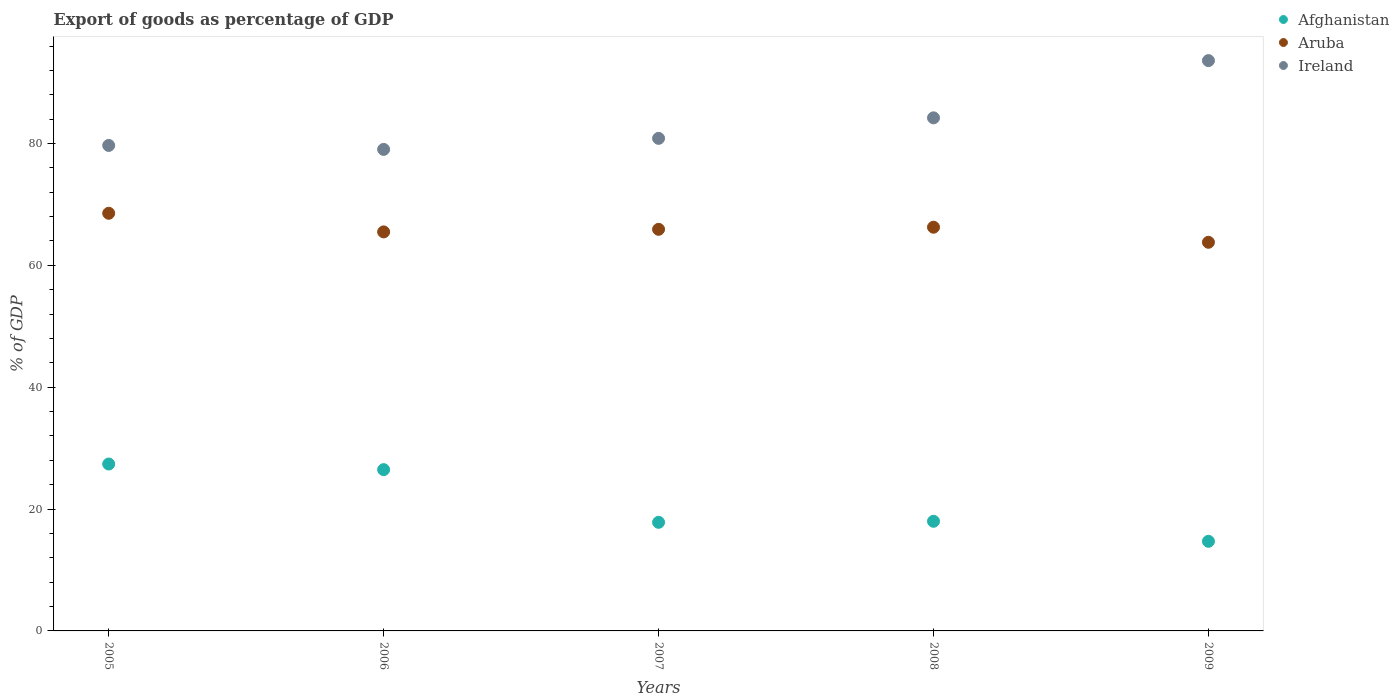What is the export of goods as percentage of GDP in Ireland in 2008?
Make the answer very short. 84.21. Across all years, what is the maximum export of goods as percentage of GDP in Ireland?
Your answer should be compact. 93.6. Across all years, what is the minimum export of goods as percentage of GDP in Ireland?
Provide a short and direct response. 79.03. In which year was the export of goods as percentage of GDP in Ireland maximum?
Offer a very short reply. 2009. What is the total export of goods as percentage of GDP in Afghanistan in the graph?
Your response must be concise. 104.39. What is the difference between the export of goods as percentage of GDP in Afghanistan in 2006 and that in 2007?
Offer a terse response. 8.65. What is the difference between the export of goods as percentage of GDP in Ireland in 2005 and the export of goods as percentage of GDP in Aruba in 2009?
Provide a succinct answer. 15.9. What is the average export of goods as percentage of GDP in Aruba per year?
Give a very brief answer. 66. In the year 2009, what is the difference between the export of goods as percentage of GDP in Afghanistan and export of goods as percentage of GDP in Aruba?
Your answer should be compact. -49.08. What is the ratio of the export of goods as percentage of GDP in Aruba in 2007 to that in 2008?
Provide a short and direct response. 0.99. What is the difference between the highest and the second highest export of goods as percentage of GDP in Afghanistan?
Give a very brief answer. 0.92. What is the difference between the highest and the lowest export of goods as percentage of GDP in Aruba?
Provide a short and direct response. 4.76. In how many years, is the export of goods as percentage of GDP in Aruba greater than the average export of goods as percentage of GDP in Aruba taken over all years?
Your answer should be very brief. 2. Is the sum of the export of goods as percentage of GDP in Afghanistan in 2005 and 2007 greater than the maximum export of goods as percentage of GDP in Ireland across all years?
Provide a succinct answer. No. Is it the case that in every year, the sum of the export of goods as percentage of GDP in Aruba and export of goods as percentage of GDP in Afghanistan  is greater than the export of goods as percentage of GDP in Ireland?
Provide a short and direct response. No. Does the export of goods as percentage of GDP in Ireland monotonically increase over the years?
Provide a short and direct response. No. Is the export of goods as percentage of GDP in Afghanistan strictly less than the export of goods as percentage of GDP in Ireland over the years?
Keep it short and to the point. Yes. How many dotlines are there?
Offer a very short reply. 3. How many years are there in the graph?
Provide a short and direct response. 5. What is the difference between two consecutive major ticks on the Y-axis?
Offer a terse response. 20. Does the graph contain grids?
Keep it short and to the point. No. How many legend labels are there?
Offer a terse response. 3. What is the title of the graph?
Your answer should be compact. Export of goods as percentage of GDP. What is the label or title of the X-axis?
Provide a short and direct response. Years. What is the label or title of the Y-axis?
Your response must be concise. % of GDP. What is the % of GDP in Afghanistan in 2005?
Your answer should be compact. 27.4. What is the % of GDP in Aruba in 2005?
Keep it short and to the point. 68.55. What is the % of GDP of Ireland in 2005?
Provide a succinct answer. 79.68. What is the % of GDP in Afghanistan in 2006?
Your response must be concise. 26.47. What is the % of GDP in Aruba in 2006?
Give a very brief answer. 65.49. What is the % of GDP in Ireland in 2006?
Ensure brevity in your answer.  79.03. What is the % of GDP in Afghanistan in 2007?
Ensure brevity in your answer.  17.82. What is the % of GDP in Aruba in 2007?
Make the answer very short. 65.91. What is the % of GDP in Ireland in 2007?
Provide a short and direct response. 80.84. What is the % of GDP in Afghanistan in 2008?
Give a very brief answer. 17.99. What is the % of GDP of Aruba in 2008?
Your response must be concise. 66.26. What is the % of GDP of Ireland in 2008?
Your answer should be compact. 84.21. What is the % of GDP in Afghanistan in 2009?
Keep it short and to the point. 14.71. What is the % of GDP of Aruba in 2009?
Provide a succinct answer. 63.79. What is the % of GDP of Ireland in 2009?
Your response must be concise. 93.6. Across all years, what is the maximum % of GDP in Afghanistan?
Your answer should be compact. 27.4. Across all years, what is the maximum % of GDP in Aruba?
Provide a short and direct response. 68.55. Across all years, what is the maximum % of GDP in Ireland?
Provide a succinct answer. 93.6. Across all years, what is the minimum % of GDP of Afghanistan?
Provide a succinct answer. 14.71. Across all years, what is the minimum % of GDP of Aruba?
Offer a very short reply. 63.79. Across all years, what is the minimum % of GDP in Ireland?
Make the answer very short. 79.03. What is the total % of GDP in Afghanistan in the graph?
Your answer should be very brief. 104.39. What is the total % of GDP in Aruba in the graph?
Keep it short and to the point. 330. What is the total % of GDP of Ireland in the graph?
Offer a very short reply. 417.38. What is the difference between the % of GDP in Afghanistan in 2005 and that in 2006?
Your answer should be very brief. 0.93. What is the difference between the % of GDP of Aruba in 2005 and that in 2006?
Provide a short and direct response. 3.06. What is the difference between the % of GDP in Ireland in 2005 and that in 2006?
Give a very brief answer. 0.65. What is the difference between the % of GDP of Afghanistan in 2005 and that in 2007?
Make the answer very short. 9.57. What is the difference between the % of GDP in Aruba in 2005 and that in 2007?
Provide a succinct answer. 2.63. What is the difference between the % of GDP in Ireland in 2005 and that in 2007?
Make the answer very short. -1.16. What is the difference between the % of GDP in Afghanistan in 2005 and that in 2008?
Make the answer very short. 9.4. What is the difference between the % of GDP of Aruba in 2005 and that in 2008?
Give a very brief answer. 2.29. What is the difference between the % of GDP in Ireland in 2005 and that in 2008?
Your response must be concise. -4.53. What is the difference between the % of GDP of Afghanistan in 2005 and that in 2009?
Provide a succinct answer. 12.69. What is the difference between the % of GDP of Aruba in 2005 and that in 2009?
Offer a very short reply. 4.76. What is the difference between the % of GDP of Ireland in 2005 and that in 2009?
Provide a succinct answer. -13.92. What is the difference between the % of GDP of Afghanistan in 2006 and that in 2007?
Your answer should be compact. 8.65. What is the difference between the % of GDP of Aruba in 2006 and that in 2007?
Offer a very short reply. -0.42. What is the difference between the % of GDP of Ireland in 2006 and that in 2007?
Your response must be concise. -1.81. What is the difference between the % of GDP in Afghanistan in 2006 and that in 2008?
Give a very brief answer. 8.48. What is the difference between the % of GDP of Aruba in 2006 and that in 2008?
Your answer should be compact. -0.77. What is the difference between the % of GDP of Ireland in 2006 and that in 2008?
Your response must be concise. -5.18. What is the difference between the % of GDP in Afghanistan in 2006 and that in 2009?
Keep it short and to the point. 11.76. What is the difference between the % of GDP in Aruba in 2006 and that in 2009?
Provide a succinct answer. 1.7. What is the difference between the % of GDP of Ireland in 2006 and that in 2009?
Ensure brevity in your answer.  -14.57. What is the difference between the % of GDP in Afghanistan in 2007 and that in 2008?
Make the answer very short. -0.17. What is the difference between the % of GDP of Aruba in 2007 and that in 2008?
Make the answer very short. -0.35. What is the difference between the % of GDP of Ireland in 2007 and that in 2008?
Your answer should be very brief. -3.37. What is the difference between the % of GDP in Afghanistan in 2007 and that in 2009?
Your response must be concise. 3.12. What is the difference between the % of GDP of Aruba in 2007 and that in 2009?
Provide a succinct answer. 2.13. What is the difference between the % of GDP of Ireland in 2007 and that in 2009?
Your answer should be very brief. -12.76. What is the difference between the % of GDP of Afghanistan in 2008 and that in 2009?
Give a very brief answer. 3.29. What is the difference between the % of GDP in Aruba in 2008 and that in 2009?
Keep it short and to the point. 2.47. What is the difference between the % of GDP of Ireland in 2008 and that in 2009?
Ensure brevity in your answer.  -9.39. What is the difference between the % of GDP of Afghanistan in 2005 and the % of GDP of Aruba in 2006?
Provide a succinct answer. -38.1. What is the difference between the % of GDP in Afghanistan in 2005 and the % of GDP in Ireland in 2006?
Keep it short and to the point. -51.64. What is the difference between the % of GDP of Aruba in 2005 and the % of GDP of Ireland in 2006?
Provide a succinct answer. -10.48. What is the difference between the % of GDP in Afghanistan in 2005 and the % of GDP in Aruba in 2007?
Provide a short and direct response. -38.52. What is the difference between the % of GDP of Afghanistan in 2005 and the % of GDP of Ireland in 2007?
Provide a succinct answer. -53.45. What is the difference between the % of GDP in Aruba in 2005 and the % of GDP in Ireland in 2007?
Your response must be concise. -12.3. What is the difference between the % of GDP of Afghanistan in 2005 and the % of GDP of Aruba in 2008?
Your answer should be very brief. -38.87. What is the difference between the % of GDP in Afghanistan in 2005 and the % of GDP in Ireland in 2008?
Keep it short and to the point. -56.82. What is the difference between the % of GDP of Aruba in 2005 and the % of GDP of Ireland in 2008?
Ensure brevity in your answer.  -15.67. What is the difference between the % of GDP in Afghanistan in 2005 and the % of GDP in Aruba in 2009?
Make the answer very short. -36.39. What is the difference between the % of GDP of Afghanistan in 2005 and the % of GDP of Ireland in 2009?
Provide a succinct answer. -66.21. What is the difference between the % of GDP of Aruba in 2005 and the % of GDP of Ireland in 2009?
Keep it short and to the point. -25.06. What is the difference between the % of GDP in Afghanistan in 2006 and the % of GDP in Aruba in 2007?
Keep it short and to the point. -39.44. What is the difference between the % of GDP of Afghanistan in 2006 and the % of GDP of Ireland in 2007?
Your response must be concise. -54.37. What is the difference between the % of GDP of Aruba in 2006 and the % of GDP of Ireland in 2007?
Your response must be concise. -15.35. What is the difference between the % of GDP of Afghanistan in 2006 and the % of GDP of Aruba in 2008?
Offer a very short reply. -39.79. What is the difference between the % of GDP of Afghanistan in 2006 and the % of GDP of Ireland in 2008?
Your answer should be compact. -57.74. What is the difference between the % of GDP in Aruba in 2006 and the % of GDP in Ireland in 2008?
Your response must be concise. -18.72. What is the difference between the % of GDP in Afghanistan in 2006 and the % of GDP in Aruba in 2009?
Make the answer very short. -37.32. What is the difference between the % of GDP in Afghanistan in 2006 and the % of GDP in Ireland in 2009?
Give a very brief answer. -67.13. What is the difference between the % of GDP in Aruba in 2006 and the % of GDP in Ireland in 2009?
Your answer should be compact. -28.11. What is the difference between the % of GDP of Afghanistan in 2007 and the % of GDP of Aruba in 2008?
Your response must be concise. -48.44. What is the difference between the % of GDP of Afghanistan in 2007 and the % of GDP of Ireland in 2008?
Provide a short and direct response. -66.39. What is the difference between the % of GDP of Aruba in 2007 and the % of GDP of Ireland in 2008?
Ensure brevity in your answer.  -18.3. What is the difference between the % of GDP of Afghanistan in 2007 and the % of GDP of Aruba in 2009?
Offer a very short reply. -45.96. What is the difference between the % of GDP in Afghanistan in 2007 and the % of GDP in Ireland in 2009?
Your answer should be compact. -75.78. What is the difference between the % of GDP of Aruba in 2007 and the % of GDP of Ireland in 2009?
Your response must be concise. -27.69. What is the difference between the % of GDP in Afghanistan in 2008 and the % of GDP in Aruba in 2009?
Ensure brevity in your answer.  -45.79. What is the difference between the % of GDP of Afghanistan in 2008 and the % of GDP of Ireland in 2009?
Offer a very short reply. -75.61. What is the difference between the % of GDP in Aruba in 2008 and the % of GDP in Ireland in 2009?
Keep it short and to the point. -27.34. What is the average % of GDP in Afghanistan per year?
Provide a succinct answer. 20.88. What is the average % of GDP in Aruba per year?
Provide a succinct answer. 66. What is the average % of GDP in Ireland per year?
Ensure brevity in your answer.  83.48. In the year 2005, what is the difference between the % of GDP of Afghanistan and % of GDP of Aruba?
Keep it short and to the point. -41.15. In the year 2005, what is the difference between the % of GDP in Afghanistan and % of GDP in Ireland?
Provide a short and direct response. -52.29. In the year 2005, what is the difference between the % of GDP in Aruba and % of GDP in Ireland?
Make the answer very short. -11.13. In the year 2006, what is the difference between the % of GDP of Afghanistan and % of GDP of Aruba?
Your response must be concise. -39.02. In the year 2006, what is the difference between the % of GDP in Afghanistan and % of GDP in Ireland?
Your response must be concise. -52.56. In the year 2006, what is the difference between the % of GDP in Aruba and % of GDP in Ireland?
Offer a terse response. -13.54. In the year 2007, what is the difference between the % of GDP of Afghanistan and % of GDP of Aruba?
Make the answer very short. -48.09. In the year 2007, what is the difference between the % of GDP of Afghanistan and % of GDP of Ireland?
Your response must be concise. -63.02. In the year 2007, what is the difference between the % of GDP in Aruba and % of GDP in Ireland?
Your answer should be compact. -14.93. In the year 2008, what is the difference between the % of GDP of Afghanistan and % of GDP of Aruba?
Keep it short and to the point. -48.27. In the year 2008, what is the difference between the % of GDP in Afghanistan and % of GDP in Ireland?
Your answer should be compact. -66.22. In the year 2008, what is the difference between the % of GDP of Aruba and % of GDP of Ireland?
Offer a very short reply. -17.95. In the year 2009, what is the difference between the % of GDP of Afghanistan and % of GDP of Aruba?
Your answer should be compact. -49.08. In the year 2009, what is the difference between the % of GDP in Afghanistan and % of GDP in Ireland?
Give a very brief answer. -78.9. In the year 2009, what is the difference between the % of GDP in Aruba and % of GDP in Ireland?
Provide a short and direct response. -29.82. What is the ratio of the % of GDP of Afghanistan in 2005 to that in 2006?
Give a very brief answer. 1.03. What is the ratio of the % of GDP of Aruba in 2005 to that in 2006?
Keep it short and to the point. 1.05. What is the ratio of the % of GDP of Ireland in 2005 to that in 2006?
Provide a short and direct response. 1.01. What is the ratio of the % of GDP of Afghanistan in 2005 to that in 2007?
Offer a very short reply. 1.54. What is the ratio of the % of GDP of Aruba in 2005 to that in 2007?
Provide a short and direct response. 1.04. What is the ratio of the % of GDP in Ireland in 2005 to that in 2007?
Offer a terse response. 0.99. What is the ratio of the % of GDP of Afghanistan in 2005 to that in 2008?
Provide a succinct answer. 1.52. What is the ratio of the % of GDP of Aruba in 2005 to that in 2008?
Offer a very short reply. 1.03. What is the ratio of the % of GDP in Ireland in 2005 to that in 2008?
Your response must be concise. 0.95. What is the ratio of the % of GDP in Afghanistan in 2005 to that in 2009?
Offer a terse response. 1.86. What is the ratio of the % of GDP of Aruba in 2005 to that in 2009?
Provide a succinct answer. 1.07. What is the ratio of the % of GDP of Ireland in 2005 to that in 2009?
Offer a very short reply. 0.85. What is the ratio of the % of GDP in Afghanistan in 2006 to that in 2007?
Your answer should be compact. 1.49. What is the ratio of the % of GDP in Aruba in 2006 to that in 2007?
Ensure brevity in your answer.  0.99. What is the ratio of the % of GDP in Ireland in 2006 to that in 2007?
Ensure brevity in your answer.  0.98. What is the ratio of the % of GDP of Afghanistan in 2006 to that in 2008?
Your response must be concise. 1.47. What is the ratio of the % of GDP of Aruba in 2006 to that in 2008?
Offer a terse response. 0.99. What is the ratio of the % of GDP of Ireland in 2006 to that in 2008?
Ensure brevity in your answer.  0.94. What is the ratio of the % of GDP of Afghanistan in 2006 to that in 2009?
Offer a terse response. 1.8. What is the ratio of the % of GDP of Aruba in 2006 to that in 2009?
Provide a short and direct response. 1.03. What is the ratio of the % of GDP in Ireland in 2006 to that in 2009?
Your answer should be very brief. 0.84. What is the ratio of the % of GDP of Afghanistan in 2007 to that in 2008?
Provide a short and direct response. 0.99. What is the ratio of the % of GDP in Aruba in 2007 to that in 2008?
Your answer should be very brief. 0.99. What is the ratio of the % of GDP in Afghanistan in 2007 to that in 2009?
Ensure brevity in your answer.  1.21. What is the ratio of the % of GDP in Aruba in 2007 to that in 2009?
Give a very brief answer. 1.03. What is the ratio of the % of GDP of Ireland in 2007 to that in 2009?
Your answer should be compact. 0.86. What is the ratio of the % of GDP of Afghanistan in 2008 to that in 2009?
Make the answer very short. 1.22. What is the ratio of the % of GDP in Aruba in 2008 to that in 2009?
Your response must be concise. 1.04. What is the ratio of the % of GDP in Ireland in 2008 to that in 2009?
Offer a very short reply. 0.9. What is the difference between the highest and the second highest % of GDP in Afghanistan?
Provide a short and direct response. 0.93. What is the difference between the highest and the second highest % of GDP of Aruba?
Keep it short and to the point. 2.29. What is the difference between the highest and the second highest % of GDP in Ireland?
Ensure brevity in your answer.  9.39. What is the difference between the highest and the lowest % of GDP in Afghanistan?
Provide a short and direct response. 12.69. What is the difference between the highest and the lowest % of GDP of Aruba?
Provide a short and direct response. 4.76. What is the difference between the highest and the lowest % of GDP of Ireland?
Make the answer very short. 14.57. 